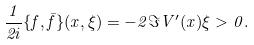Convert formula to latex. <formula><loc_0><loc_0><loc_500><loc_500>\frac { 1 } { 2 i } \{ f , \bar { f } \} ( x , \xi ) = - 2 \Im V ^ { \prime } ( x ) \xi > 0 .</formula> 